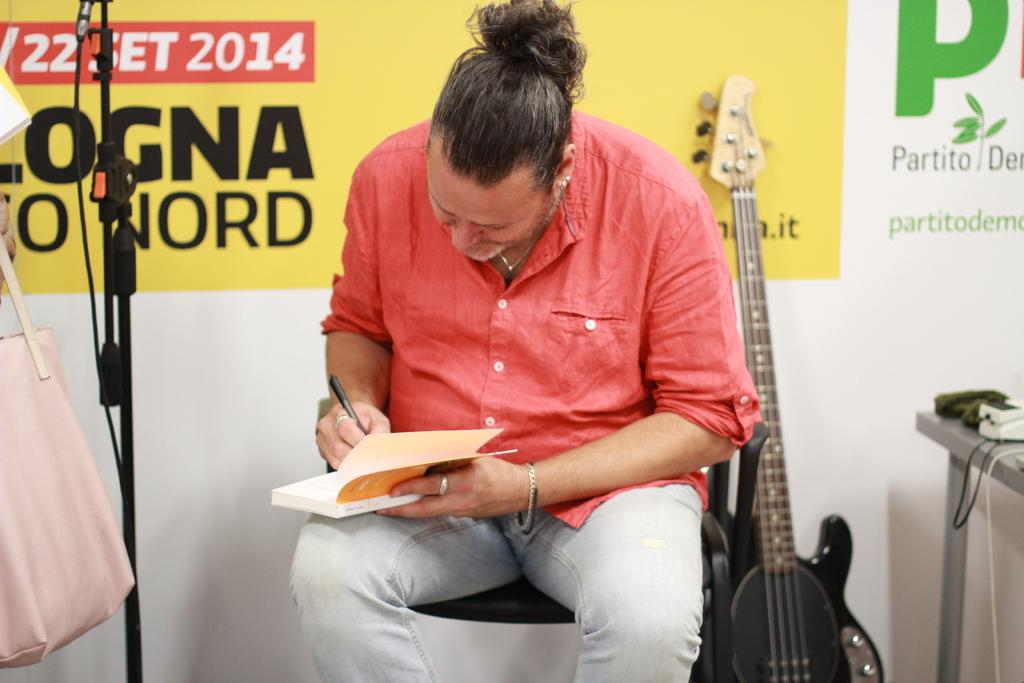<image>
Provide a brief description of the given image. A red shirted man is sitting next to a guitar and the logo for logna on the wall behind him. 